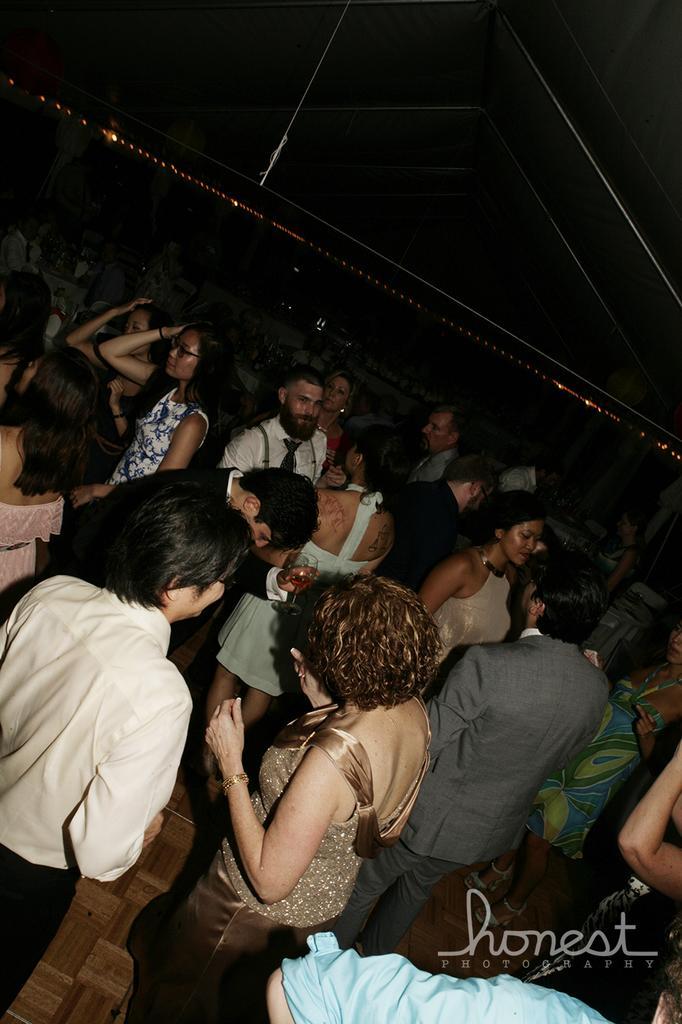In one or two sentences, can you explain what this image depicts? In this image we can see a group of people standing on the floor. At the top of the image we can see some metal poles and some lights. In the bottom right corner of the image we can see some text. 